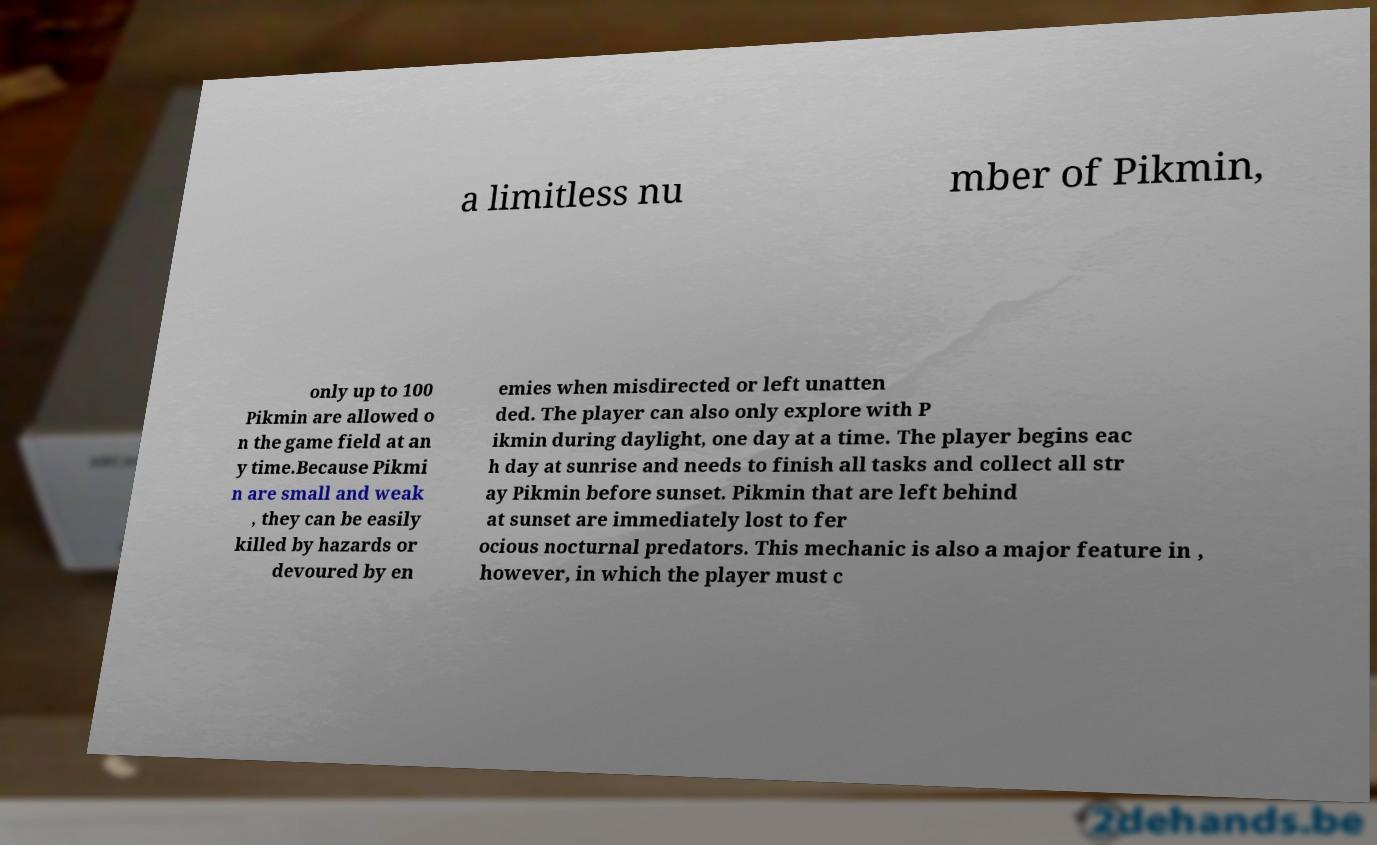Could you assist in decoding the text presented in this image and type it out clearly? a limitless nu mber of Pikmin, only up to 100 Pikmin are allowed o n the game field at an y time.Because Pikmi n are small and weak , they can be easily killed by hazards or devoured by en emies when misdirected or left unatten ded. The player can also only explore with P ikmin during daylight, one day at a time. The player begins eac h day at sunrise and needs to finish all tasks and collect all str ay Pikmin before sunset. Pikmin that are left behind at sunset are immediately lost to fer ocious nocturnal predators. This mechanic is also a major feature in , however, in which the player must c 